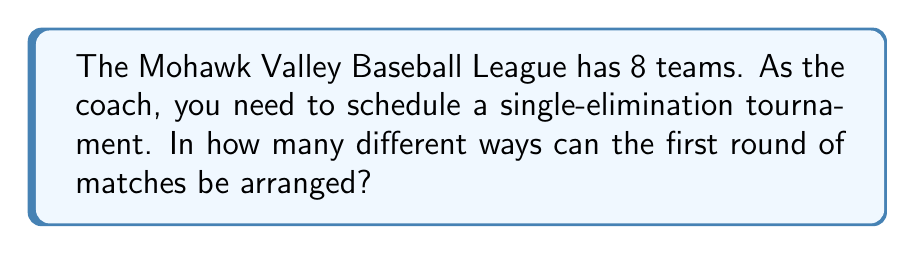Can you answer this question? Let's approach this step-by-step:

1) In a single-elimination tournament with 8 teams, there will be 4 matches in the first round.

2) We need to choose which teams play against each other in these 4 matches.

3) For the first match, we can choose any 2 teams out of 8. This can be done in $\binom{8}{2}$ ways.

4) After the first match is set, we have 6 teams left. For the second match, we choose 2 out of these 6, which can be done in $\binom{6}{2}$ ways.

5) For the third match, we choose 2 out of the remaining 4 teams: $\binom{4}{2}$ ways.

6) The last 2 teams automatically form the fourth match.

7) Therefore, the total number of ways to arrange the matches is:

   $$\frac{\binom{8}{2} \cdot \binom{6}{2} \cdot \binom{4}{2}}{4!}$$

8) We divide by 4! because the order of the 4 matches doesn't matter.

9) Let's calculate:
   $$\frac{(28 \cdot 15 \cdot 6)}{24} = \frac{2520}{24} = 105$$

Thus, there are 105 different ways to arrange the first round of matches.
Answer: 105 